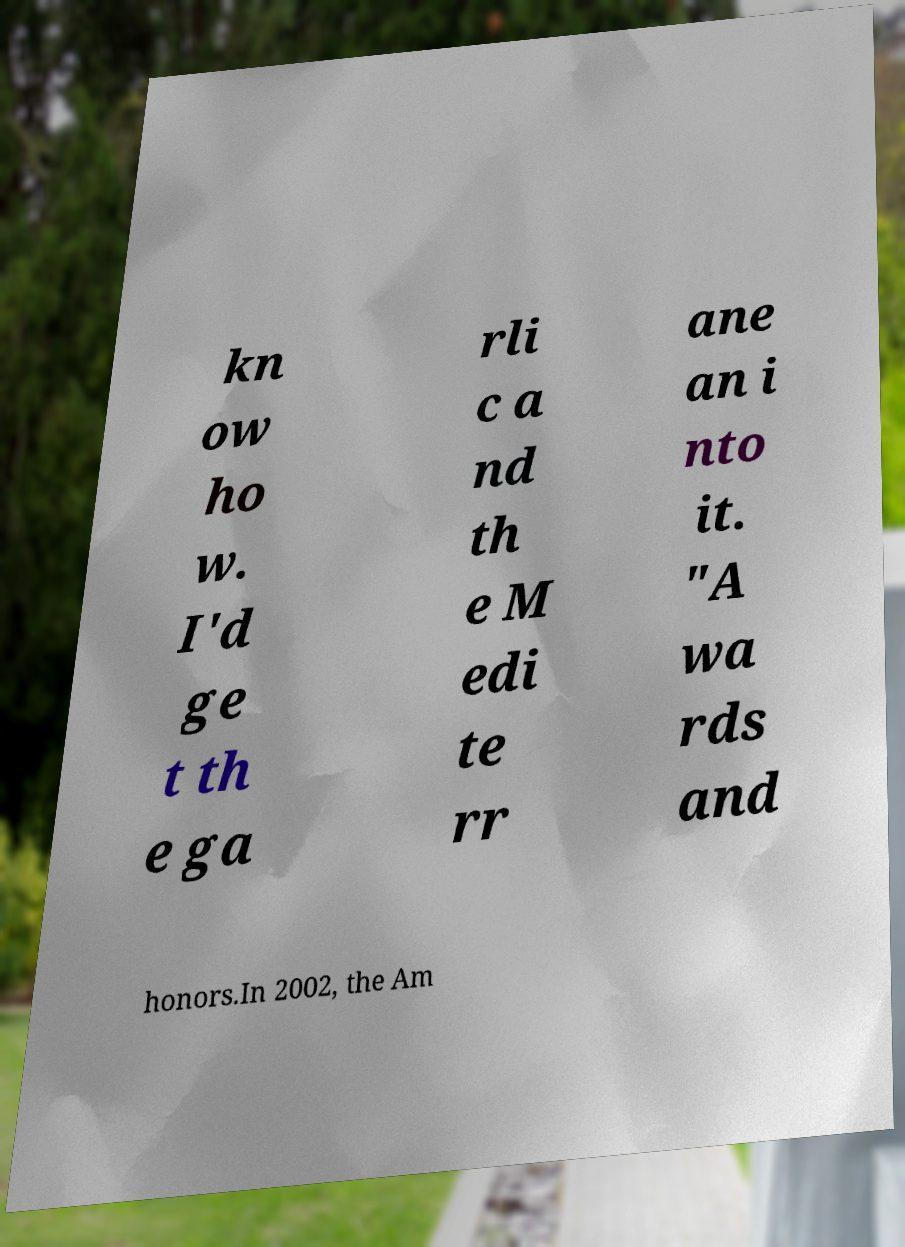Please identify and transcribe the text found in this image. kn ow ho w. I'd ge t th e ga rli c a nd th e M edi te rr ane an i nto it. "A wa rds and honors.In 2002, the Am 